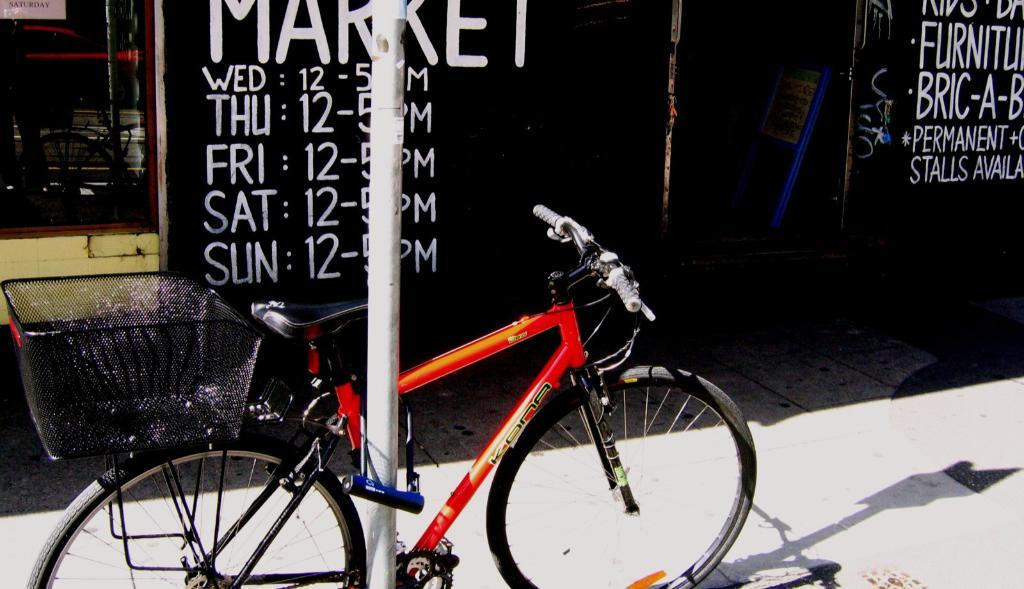What is the main subject of the image? There is a bicycle in the image. What other objects can be seen in the image? There is a pole and other objects visible in the image. What can be seen in the background of the image? There is a wall with text, a name board, a glass window, and other objects in the background of the image. What type of religion is practiced in the mine depicted in the image? There is no mine or religious practice depicted in the image; it features a bicycle, a pole, and various objects in the foreground and background. 